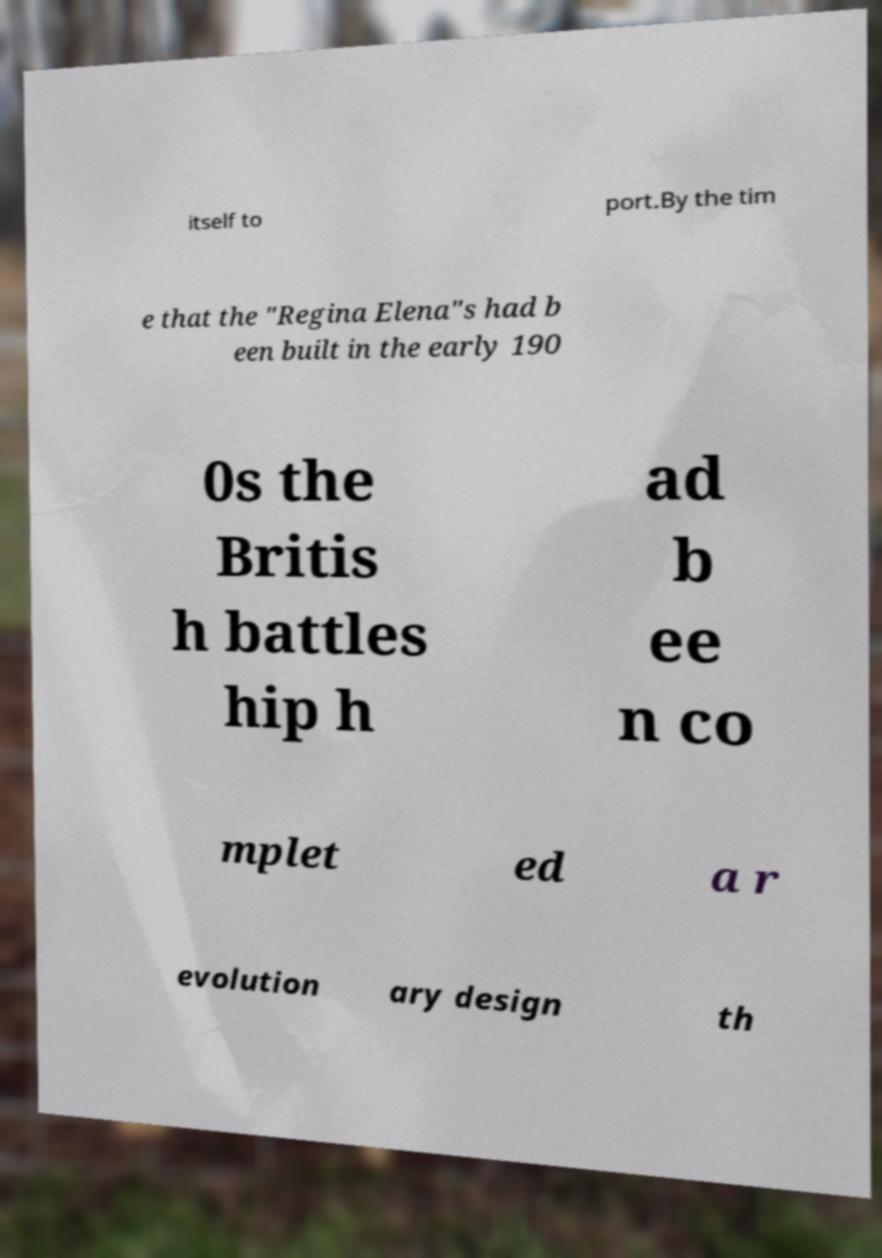Could you assist in decoding the text presented in this image and type it out clearly? itself to port.By the tim e that the "Regina Elena"s had b een built in the early 190 0s the Britis h battles hip h ad b ee n co mplet ed a r evolution ary design th 